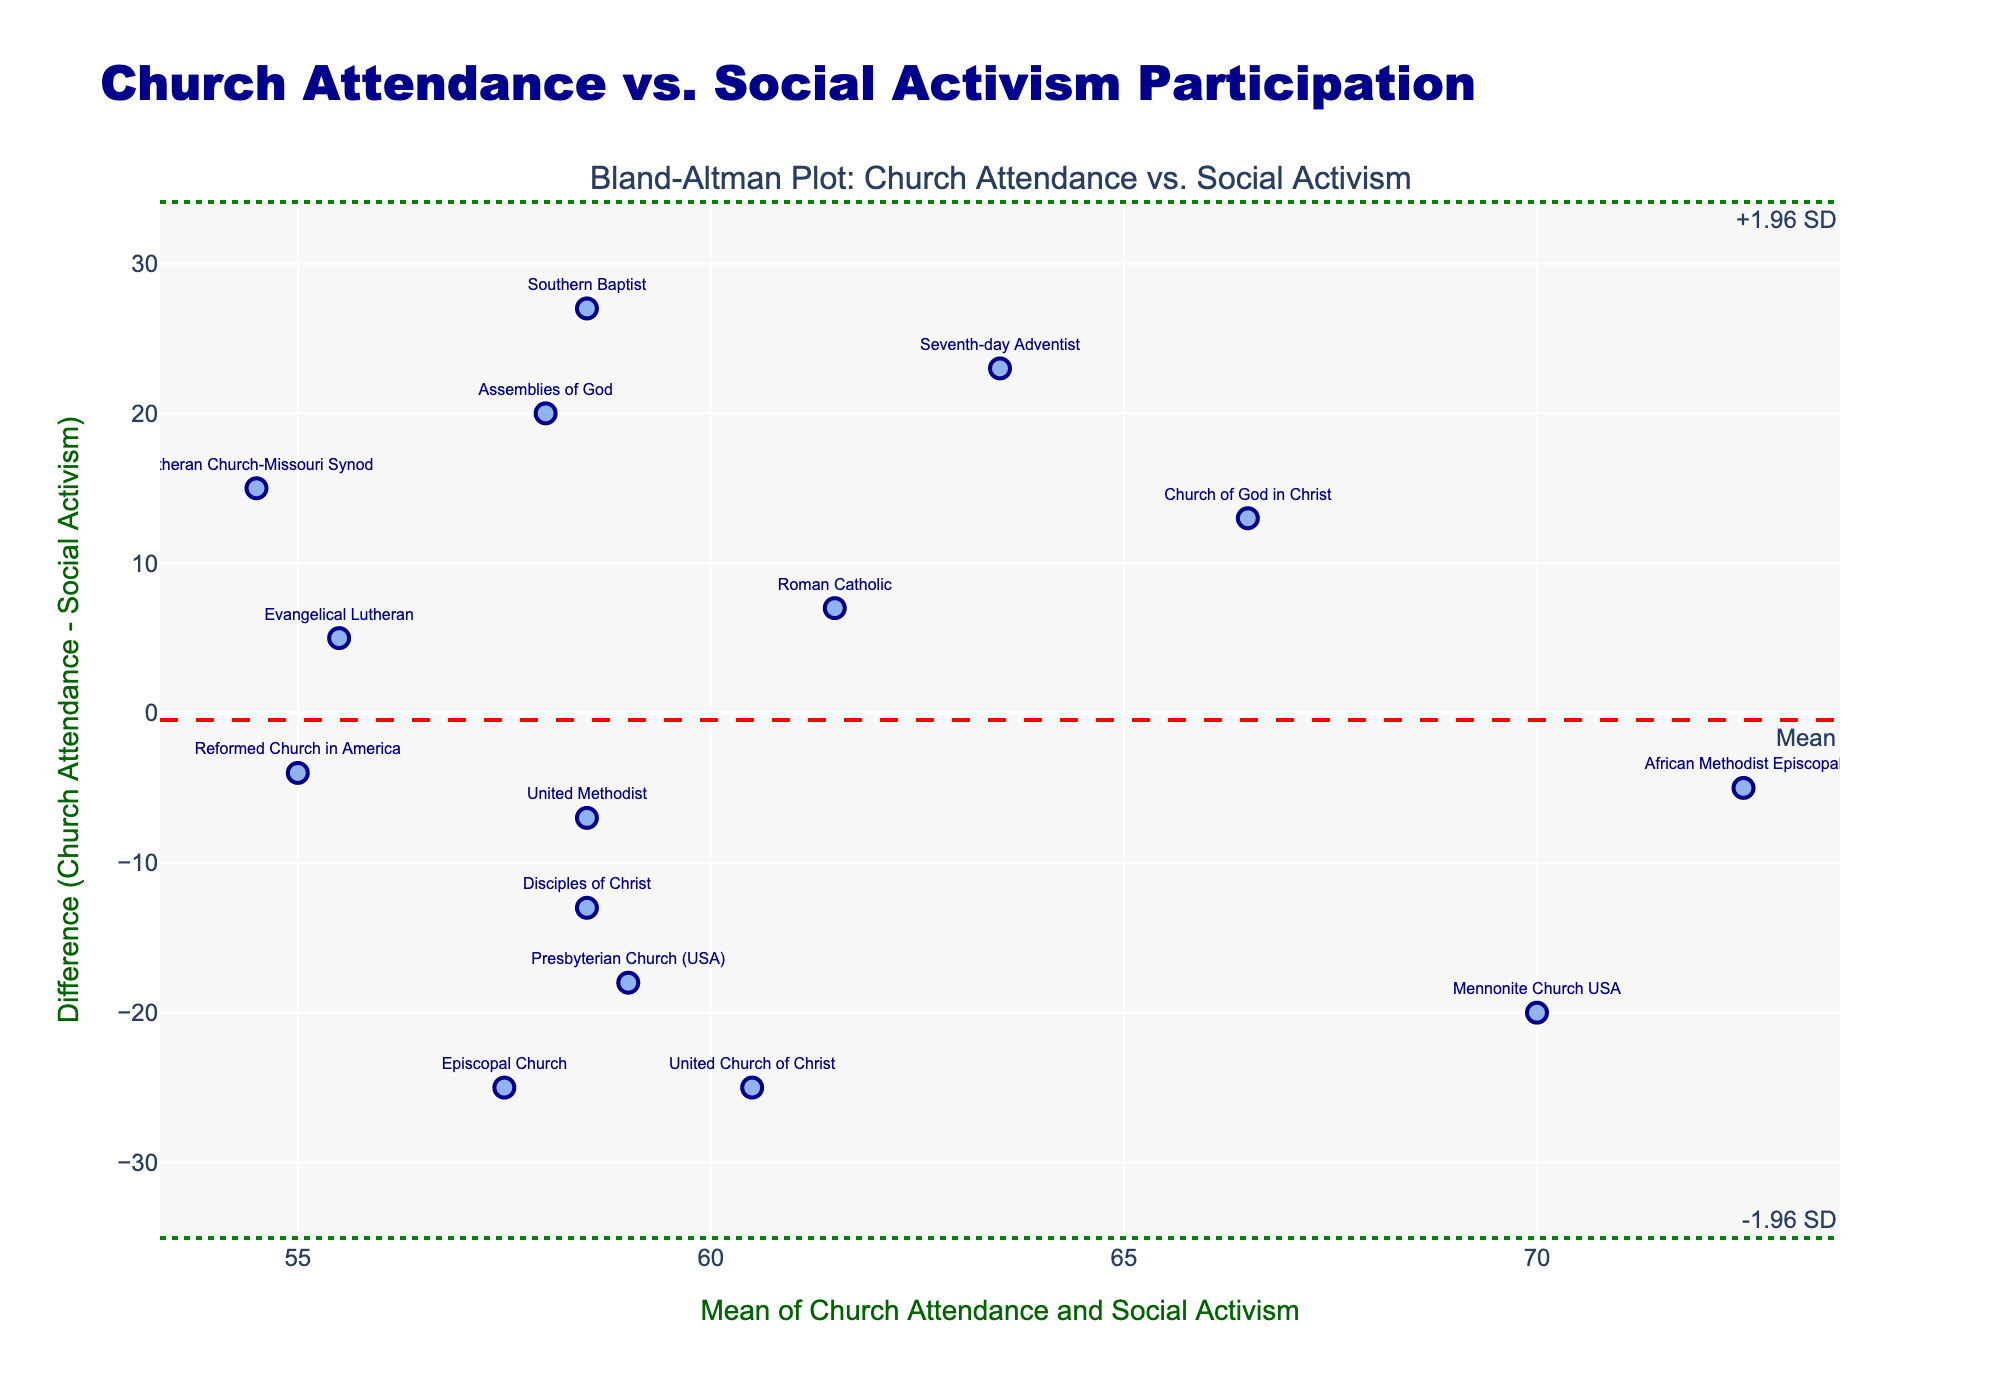How many denominations are represented in the plot? The plot includes one marker for each denomination; counting the markers gives us the number of denominations represented.
Answer: 15 What is the difference between church attendance and social activism participation for the United Church of Christ? Locate the United Church of Christ on the plot, interpret the difference value noted beside the marker.
Answer: -25 Which denomination has the highest mean value of church attendance and social activism participation? Identify the data points with the highest x-axis (mean) value; the text associated with that point shows the denomination.
Answer: Mennonite Church USA What is the overall trend observed in the plot: do most denominations have higher church attendance or social activism participation? By looking at the y-axis, if most data points are above the zero line, the general trend is higher church attendance; below indicates higher social activism.
Answer: Higher Church Attendance Which denominations lie outside the ±1.96 SD limits? Identify markers placed above and below the lines labeled +1.96 SD and -1.96 SD to determine which denominations exceed these limits.
Answer: United Church of Christ and African Methodist Episcopal What denotes the green dotted lines on the plot? The green dotted lines represent ±1.96 standard deviations from the mean difference, as indicated by their labels.
Answer: ±1.96 SD What is the mean difference between church attendance and social activism participation? Identify the red dashed line and its associated value on the plot, which marks the mean difference.
Answer: -4 Which denomination has the most significant positive difference between church attendance and social activism participation? Find the highest marker above the zero line on the y-axis; the text closest to this marker shows the denomination.
Answer: Southern Baptist Between Evangelical Lutheran and Lutheran Church-Missouri Synod, which has a higher church attendance compared to social activism participation? Compare the difference values for both denominations noted on the plot. The one with a positive difference has higher attendance.
Answer: Lutheran Church-Missouri Synod How is the plot title related to the data being visualized? The title "Church Attendance vs. Social Activism Participation" indicates that the plot compares these two metrics for various denominations using a Bland-Altman plot method.
Answer: Compares church attendance and social activism 